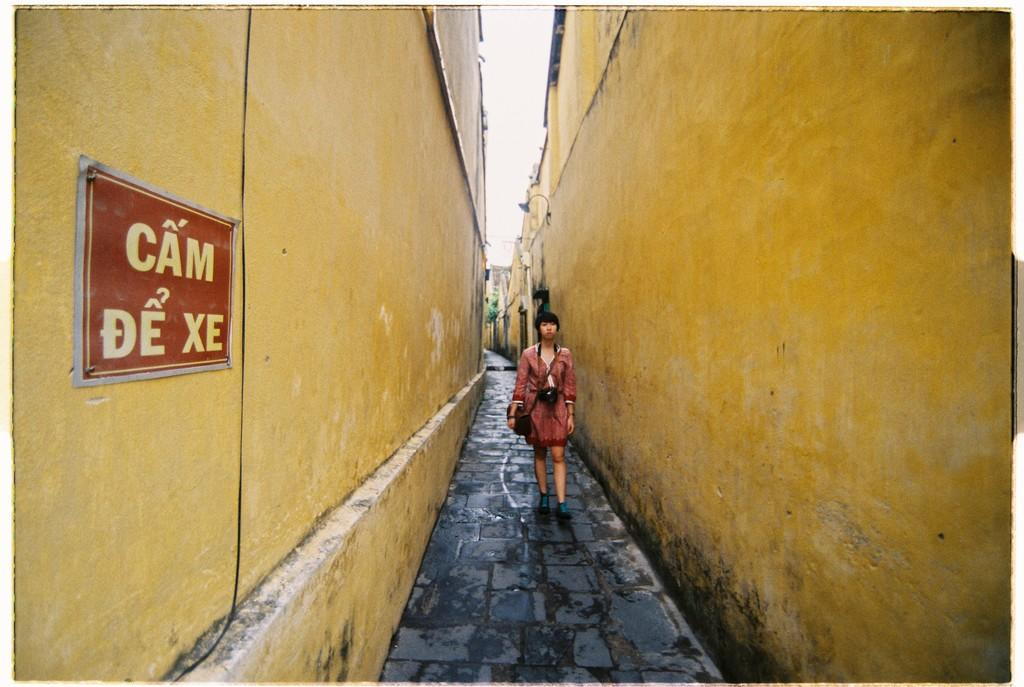<image>
Present a compact description of the photo's key features. Street ally with yellow building walls and a sign saying cam de xe. 